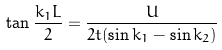Convert formula to latex. <formula><loc_0><loc_0><loc_500><loc_500>\tan { \frac { k _ { 1 } L } { 2 } } = \frac { U } { 2 t ( \sin { k _ { 1 } } - \sin { k _ { 2 } } ) }</formula> 